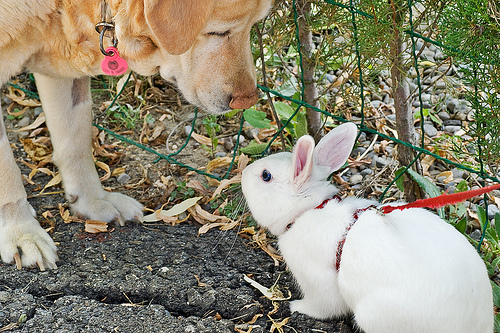<image>
Is there a dog on the rabbit? No. The dog is not positioned on the rabbit. They may be near each other, but the dog is not supported by or resting on top of the rabbit. Where is the rabbit in relation to the dog? Is it to the left of the dog? No. The rabbit is not to the left of the dog. From this viewpoint, they have a different horizontal relationship. Where is the dog in relation to the fence? Is it behind the fence? No. The dog is not behind the fence. From this viewpoint, the dog appears to be positioned elsewhere in the scene. 